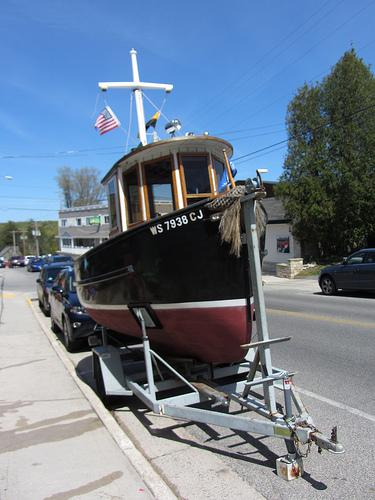Question: why is the boat on the side of the road?
Choices:
A. To be repaired.
B. To be loaded and transported somewhere.
C. To show it off.
D. To be sold.
Answer with the letter. Answer: C Question: how is the boat standing?
Choices:
A. With a trailer.
B. On braces.
C. On blocks.
D. On a lift.
Answer with the letter. Answer: A Question: what are the letters on the boat?
Choices:
A. Uss rdj.
B. R2d2.
C. Ws cj.
D. C3po.
Answer with the letter. Answer: C 